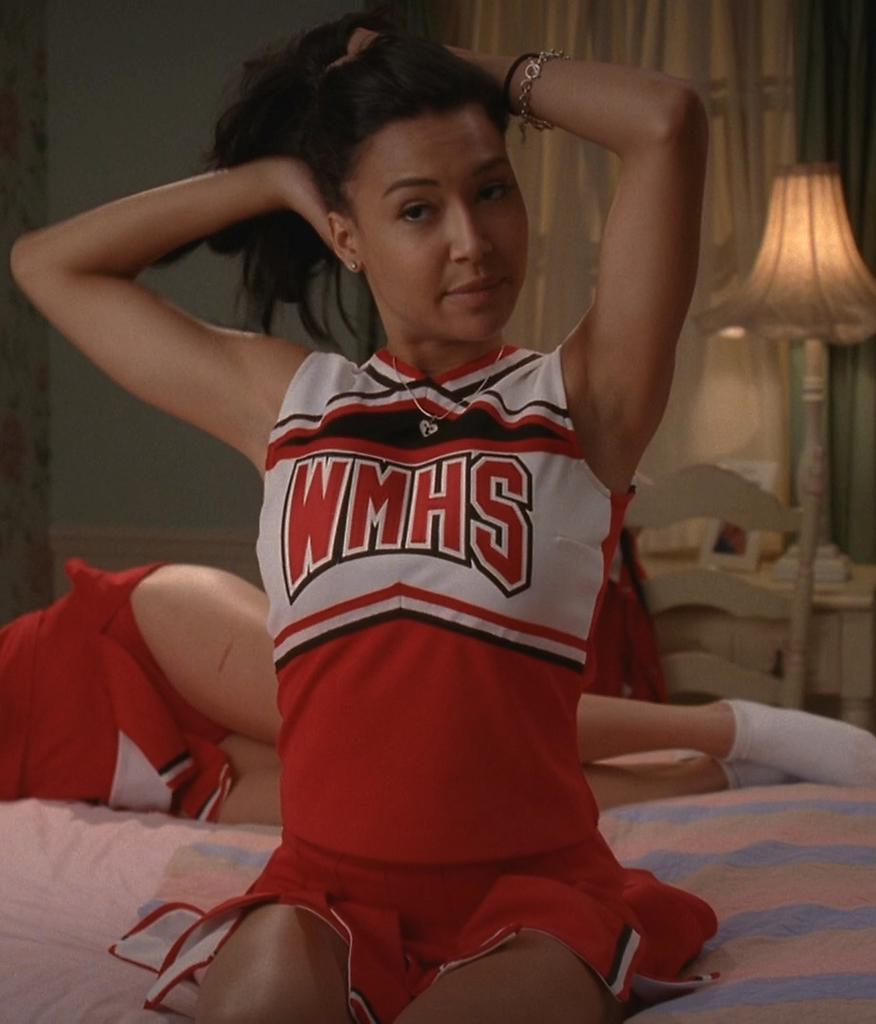<image>
Present a compact description of the photo's key features. An attractive cheerleader sits on a bed with WMHS written on her top. 